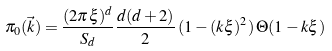<formula> <loc_0><loc_0><loc_500><loc_500>\pi _ { 0 } ( \vec { k } ) = \frac { ( 2 \pi \xi ) ^ { d } } { S _ { d } } \frac { d ( d + 2 ) } { 2 } \, ( 1 - ( k \xi ) ^ { 2 } ) \, \Theta ( 1 - k \xi )</formula> 